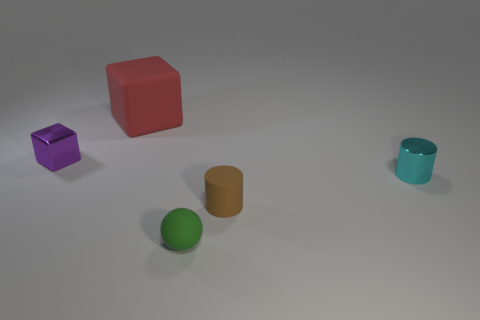Add 3 matte spheres. How many objects exist? 8 Subtract all blue cylinders. How many yellow balls are left? 0 Subtract all brown cylinders. Subtract all green matte balls. How many objects are left? 3 Add 4 small brown objects. How many small brown objects are left? 5 Add 3 small shiny blocks. How many small shiny blocks exist? 4 Subtract all red blocks. How many blocks are left? 1 Subtract 1 red blocks. How many objects are left? 4 Subtract all balls. How many objects are left? 4 Subtract 1 balls. How many balls are left? 0 Subtract all yellow blocks. Subtract all red balls. How many blocks are left? 2 